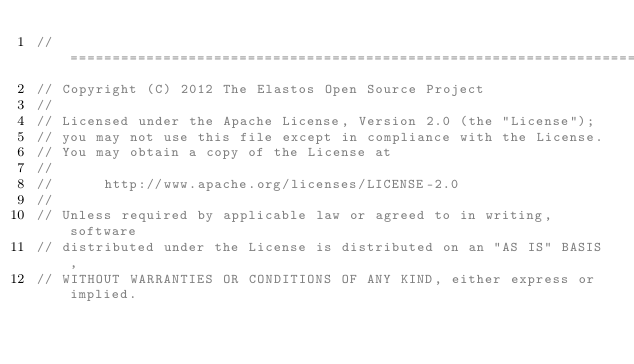<code> <loc_0><loc_0><loc_500><loc_500><_C_>//=========================================================================
// Copyright (C) 2012 The Elastos Open Source Project
//
// Licensed under the Apache License, Version 2.0 (the "License");
// you may not use this file except in compliance with the License.
// You may obtain a copy of the License at
//
//      http://www.apache.org/licenses/LICENSE-2.0
//
// Unless required by applicable law or agreed to in writing, software
// distributed under the License is distributed on an "AS IS" BASIS,
// WITHOUT WARRANTIES OR CONDITIONS OF ANY KIND, either express or implied.</code> 